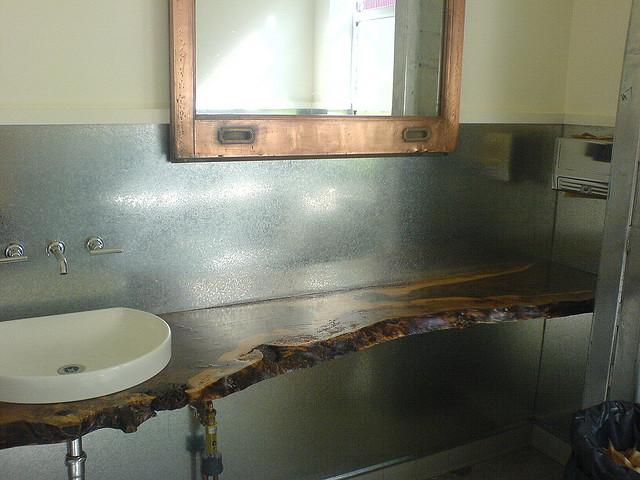What is the counter made of?
Concise answer only. Wood. What is hanging on the wall?
Answer briefly. Mirror. What is built into the counter?
Give a very brief answer. Sink. 